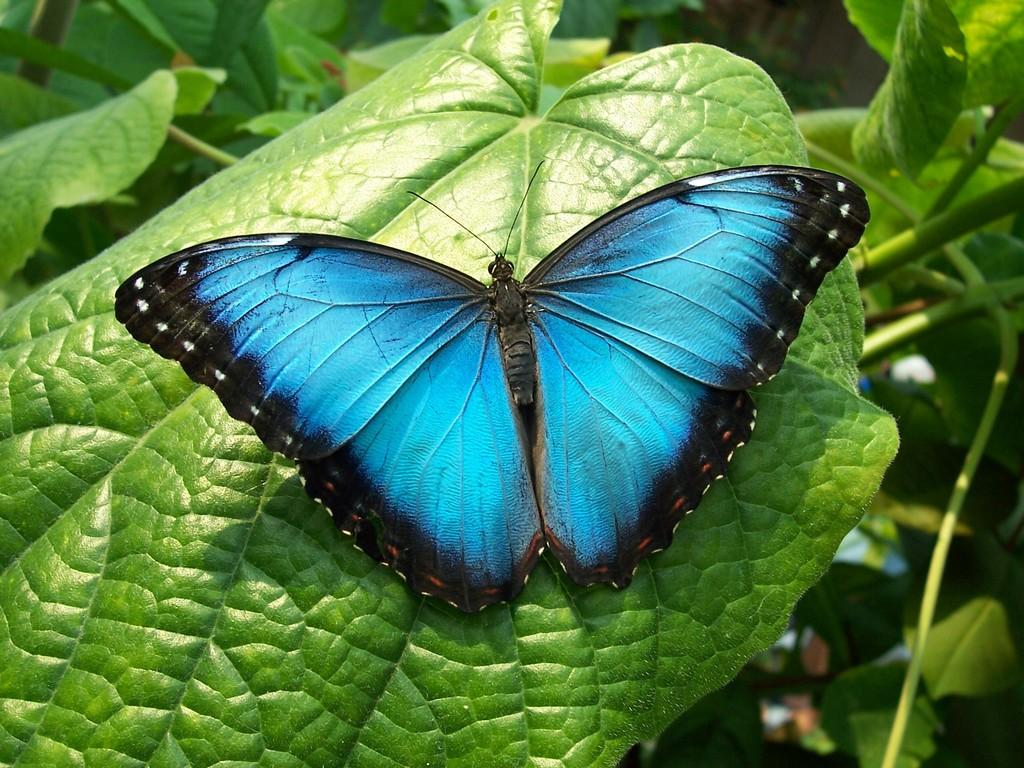What type of natural elements can be seen in the image? There are leaves in the image. What kind of insect is present in the image? There is a blue butterfly in the image. What color are the butterfly's wings? The butterfly has blue wings. What type of voice can be heard coming from the butterfly in the image? Butterflies do not have voices, so there is no voice coming from the butterfly in the image. Is there a team of butterflies working together in the image? There is only one butterfly visible in the image, so there is no team of butterflies present. 